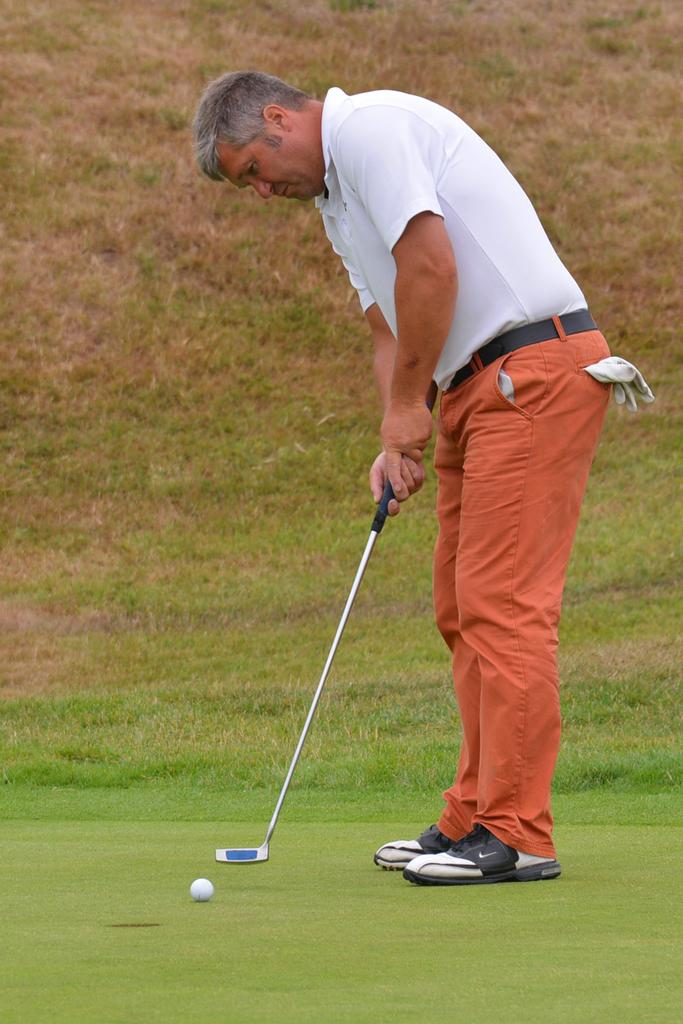What is the main subject of the image? There is a person in the image. What object is on the ground in the image? There is a ball on the ground in the image. What is the person holding in the image? The person is holding a stick. What type of natural environment is visible in the background of the image? There is grass visible in the background of the image. What type of dress is the person wearing in the image? The provided facts do not mention any dress or clothing worn by the person in the image. 